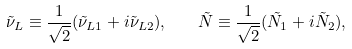Convert formula to latex. <formula><loc_0><loc_0><loc_500><loc_500>\tilde { \nu } _ { L } \equiv \frac { 1 } { \sqrt { 2 } } ( \tilde { \nu } _ { L 1 } + i \tilde { \nu } _ { L 2 } ) , \quad \tilde { N } \equiv \frac { 1 } { \sqrt { 2 } } ( \tilde { N } _ { 1 } + i \tilde { N } _ { 2 } ) ,</formula> 